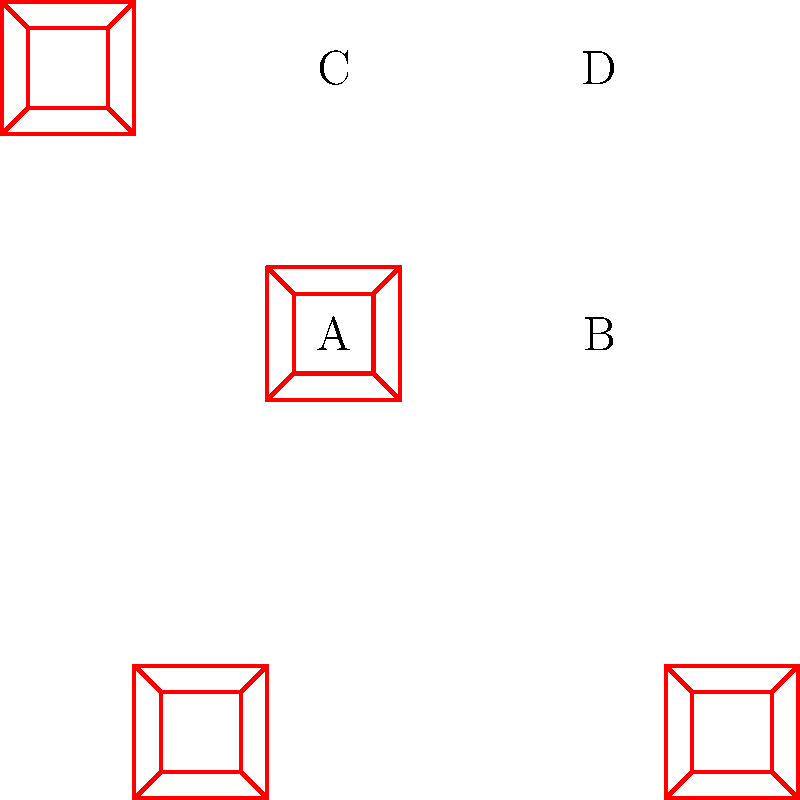In this traditional Khokhloma pattern, which shapes are congruent to each other? To determine which shapes are congruent in this Khokhloma pattern, we need to analyze the geometric properties of each shape:

1. First, observe that the pattern consists of four identical square sections, each containing a Khokhloma design.

2. Each section is a square with a smaller square inside, connected by diagonal lines.

3. The four sections are labeled A, B, C, and D.

4. To be congruent, shapes must have the same size and shape, but can be rotated or reflected.

5. Comparing the sections:
   - A and B are identical in size and shape, but B is rotated 90 degrees clockwise relative to A.
   - A and C are identical in size and shape, but C is rotated 90 degrees counterclockwise relative to A.
   - A and D are identical in size and shape, but D is rotated 180 degrees relative to A.

6. Since all four sections have the same size and shape, and differ only in rotation, they are all congruent to each other.

Therefore, shapes A, B, C, and D are all congruent to each other in this Khokhloma pattern.
Answer: A, B, C, and D 